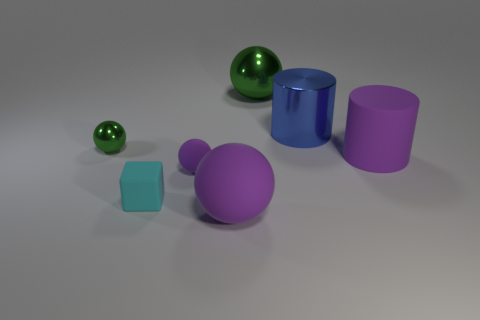Are there any other things that have the same shape as the small cyan rubber object?
Provide a succinct answer. No. There is a matte sphere in front of the cyan matte thing; is its color the same as the large rubber object that is right of the big green shiny object?
Your response must be concise. Yes. Is there a large blue shiny object of the same shape as the large green metallic object?
Ensure brevity in your answer.  No. What number of other things are there of the same color as the cube?
Provide a short and direct response. 0. There is a shiny sphere that is to the left of the shiny sphere to the right of the big object in front of the big matte cylinder; what is its color?
Make the answer very short. Green. Are there the same number of green things that are on the right side of the metallic cylinder and tiny purple things?
Provide a short and direct response. No. There is a green sphere that is on the left side of the cyan matte thing; is its size the same as the big blue cylinder?
Offer a terse response. No. How many small red rubber spheres are there?
Your response must be concise. 0. How many balls are behind the big purple matte sphere and to the right of the small cyan matte thing?
Offer a very short reply. 2. Is there a tiny sphere made of the same material as the small cube?
Make the answer very short. Yes. 